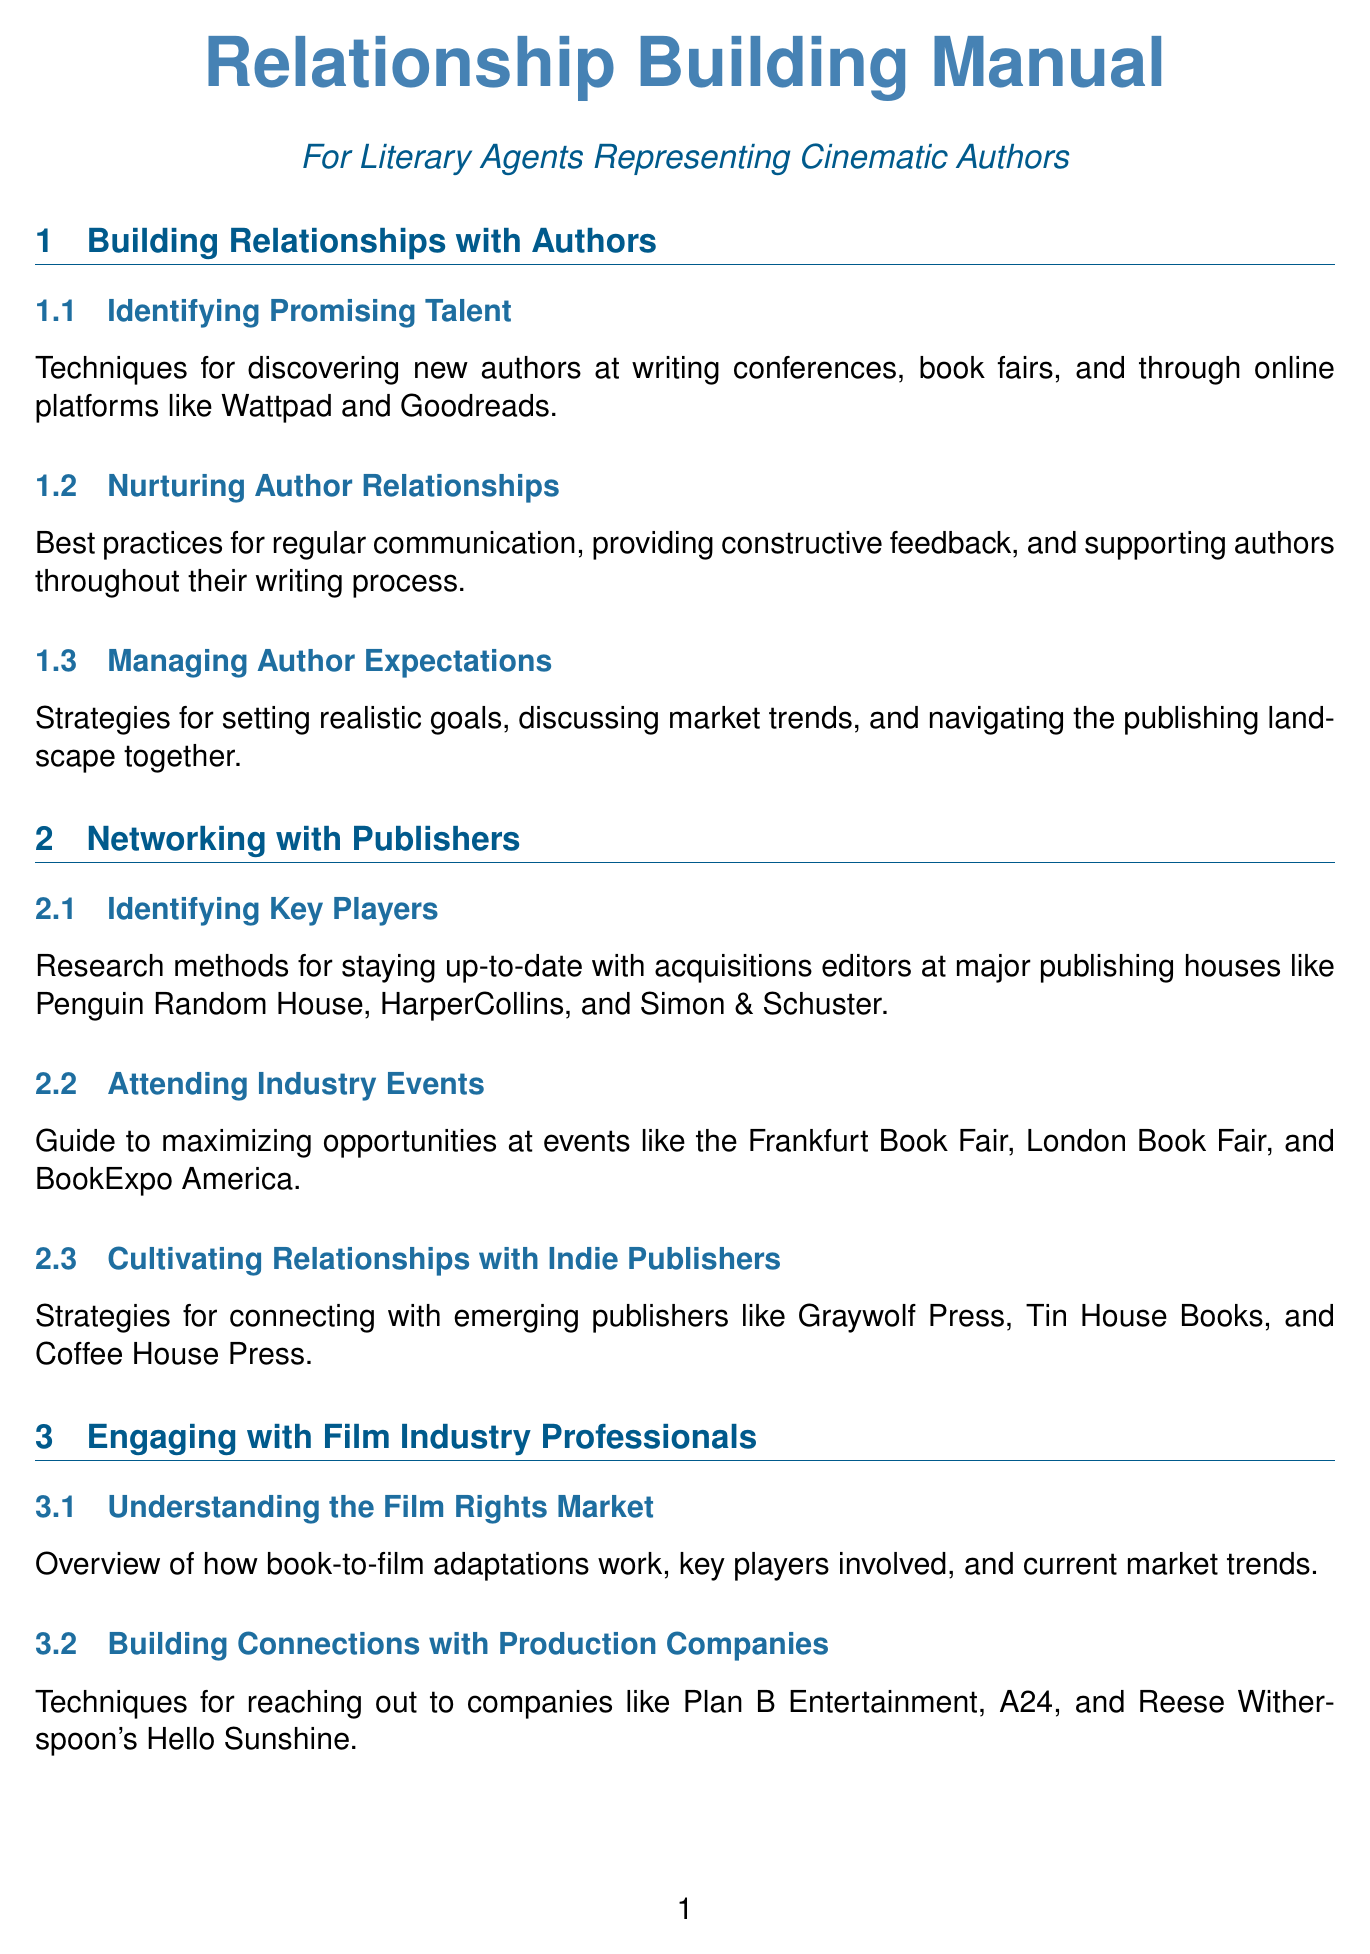What are techniques for discovering new authors? The document states that new authors can be discovered at writing conferences, book fairs, and through online platforms like Wattpad and Goodreads.
Answer: Writing conferences, book fairs, Wattpad, Goodreads Which publishing houses are mentioned for acquisitions editors? The document lists major publishing houses including Penguin Random House, HarperCollins, and Simon & Schuster for acquisitions editors.
Answer: Penguin Random House, HarperCollins, Simon & Schuster What is a key film industry event for pitching book-to-film adaptations? The document highlights the American Film Market as a key event for such pitches.
Answer: American Film Market What are the best practices for keeping in touch? The document suggests regular check-ins and updates as best practices for maintaining contact.
Answer: Regular check-ins and updates Which organization offers networking opportunities for literary agents? The Association of Authors' Representatives (AAR) is highlighted in the document as the organization providing such opportunities.
Answer: Association of Authors' Representatives (AAR) How many case studies are included in the document? The document lists three case studies detailing the careers of various agents and authors.
Answer: Three What is emphasized under 'Providing Value Beyond Representation'? The content mentions offering industry insights, career guidance, and personal support to strengthen relationships.
Answer: Industry insights, career guidance, personal support What should be mastered to connect with industry professionals? The document recommends mastering social media platforms for effective connection with industry professionals.
Answer: Social media 